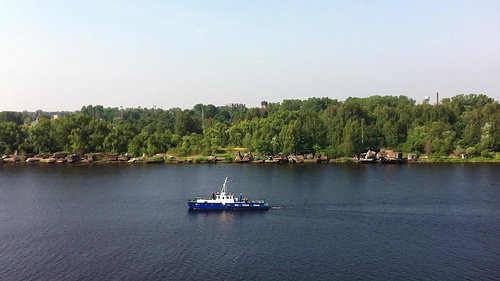Please provide a short description for this region: [0.37, 0.55, 0.55, 0.65]. A ship is captured traveling elegantly on the water in this segment, an intriguing sight against the natural backdrop. 